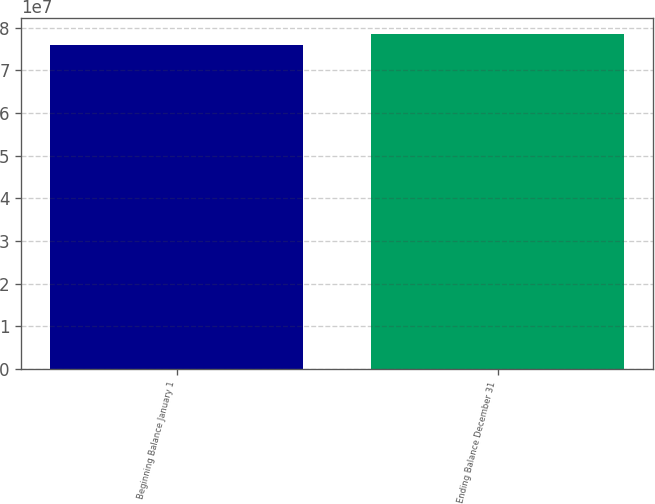Convert chart. <chart><loc_0><loc_0><loc_500><loc_500><bar_chart><fcel>Beginning Balance January 1<fcel>Ending Balance December 31<nl><fcel>7.60069e+07<fcel>7.8397e+07<nl></chart> 